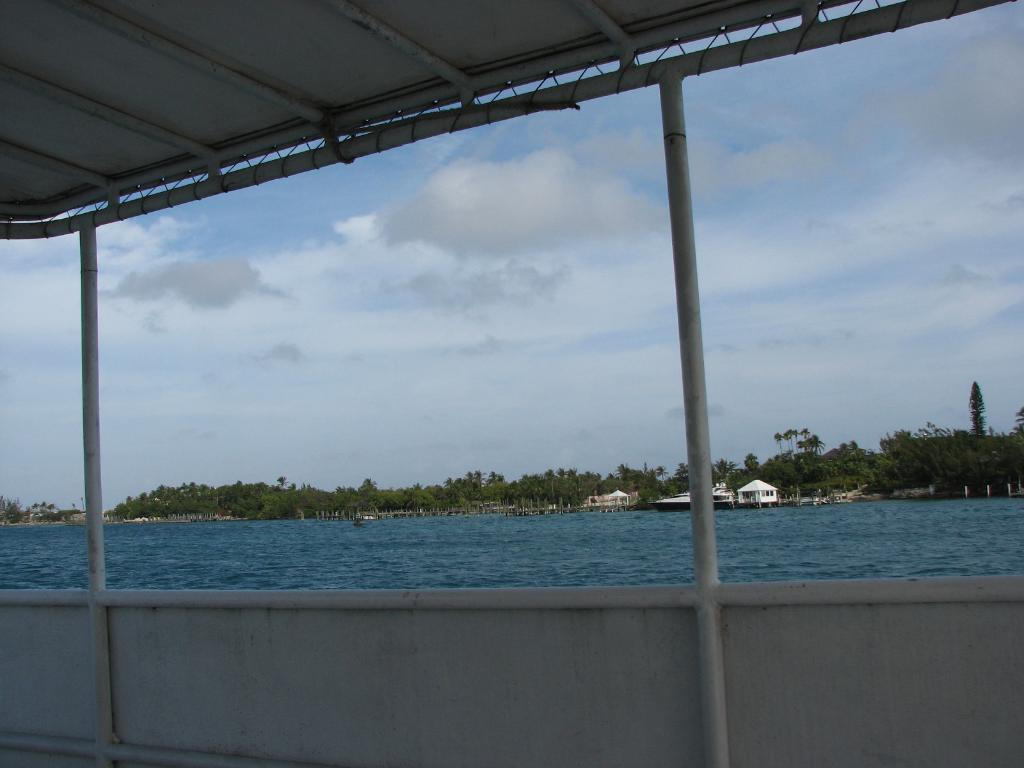What type of structure can be seen in the image? There is a shed in the image. What natural element is visible in the image? There is water visible in the image. What type of vegetation is present in the image? There are trees in the image. What type of man-made structures can be seen in the image? There are buildings in the image. What is visible in the background of the image? The sky is visible in the background of the image. What can be observed in the sky? Clouds are present in the sky. What type of thrill can be seen in the image? There is no thrill present in the image; it features a shed, water, trees, buildings, and a sky with clouds. Can you tell me how many bottles are visible in the image? There are no bottles present in the image. 